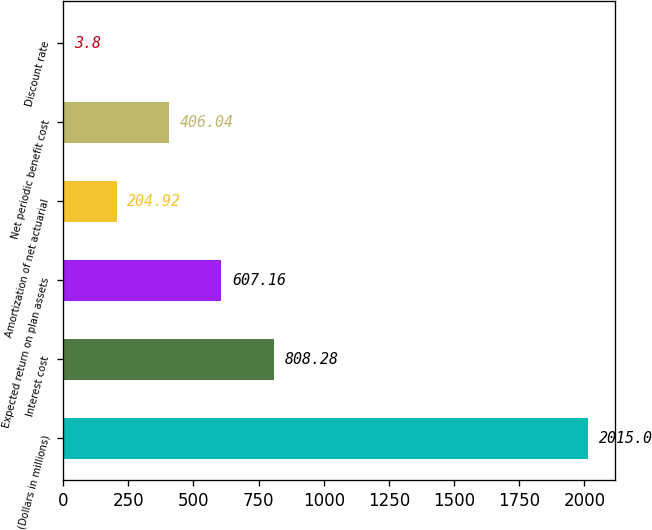Convert chart to OTSL. <chart><loc_0><loc_0><loc_500><loc_500><bar_chart><fcel>(Dollars in millions)<fcel>Interest cost<fcel>Expected return on plan assets<fcel>Amortization of net actuarial<fcel>Net periodic benefit cost<fcel>Discount rate<nl><fcel>2015<fcel>808.28<fcel>607.16<fcel>204.92<fcel>406.04<fcel>3.8<nl></chart> 